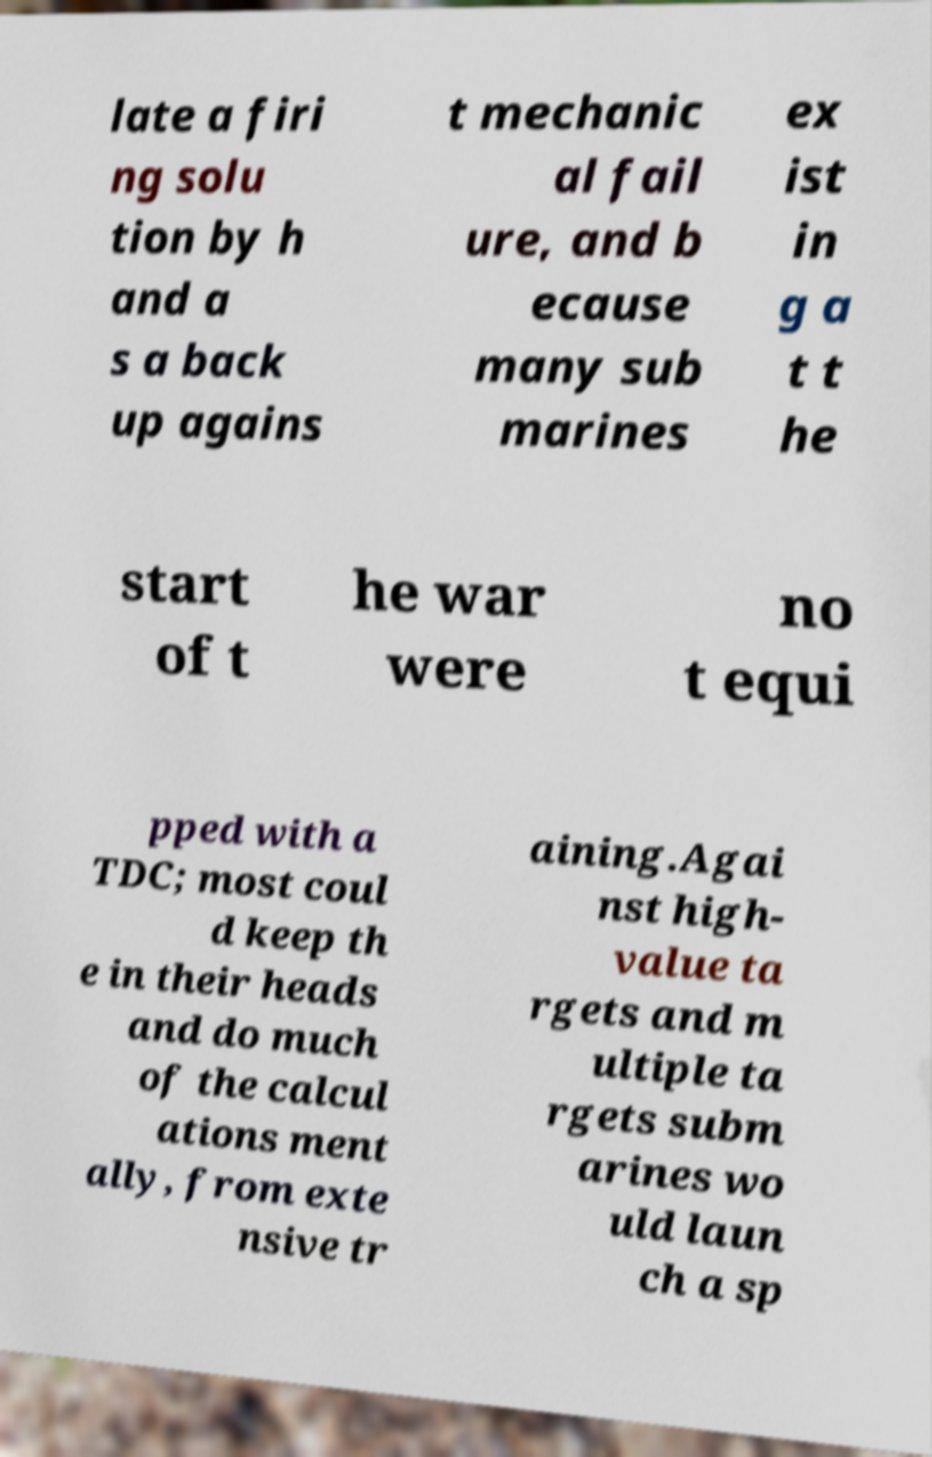Please identify and transcribe the text found in this image. late a firi ng solu tion by h and a s a back up agains t mechanic al fail ure, and b ecause many sub marines ex ist in g a t t he start of t he war were no t equi pped with a TDC; most coul d keep th e in their heads and do much of the calcul ations ment ally, from exte nsive tr aining.Agai nst high- value ta rgets and m ultiple ta rgets subm arines wo uld laun ch a sp 